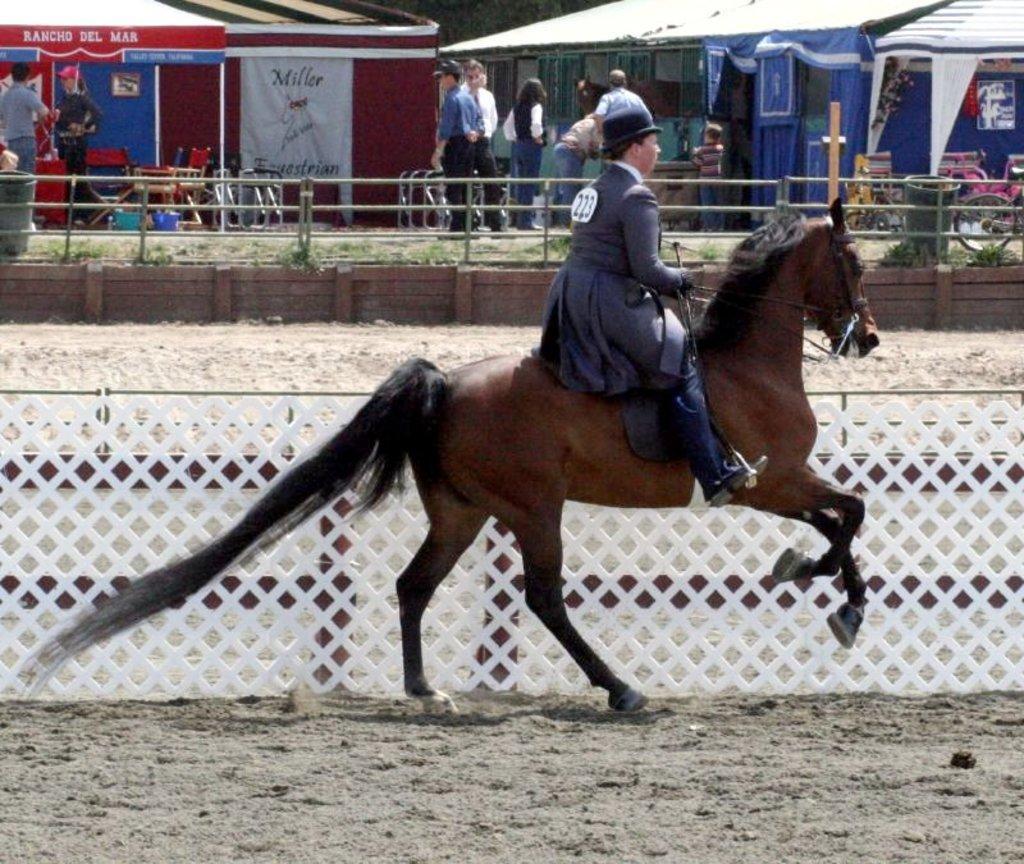Describe this image in one or two sentences. In the center of the image we can see a man riding horse. In the background we can see a fence, people standing and there are tents. 